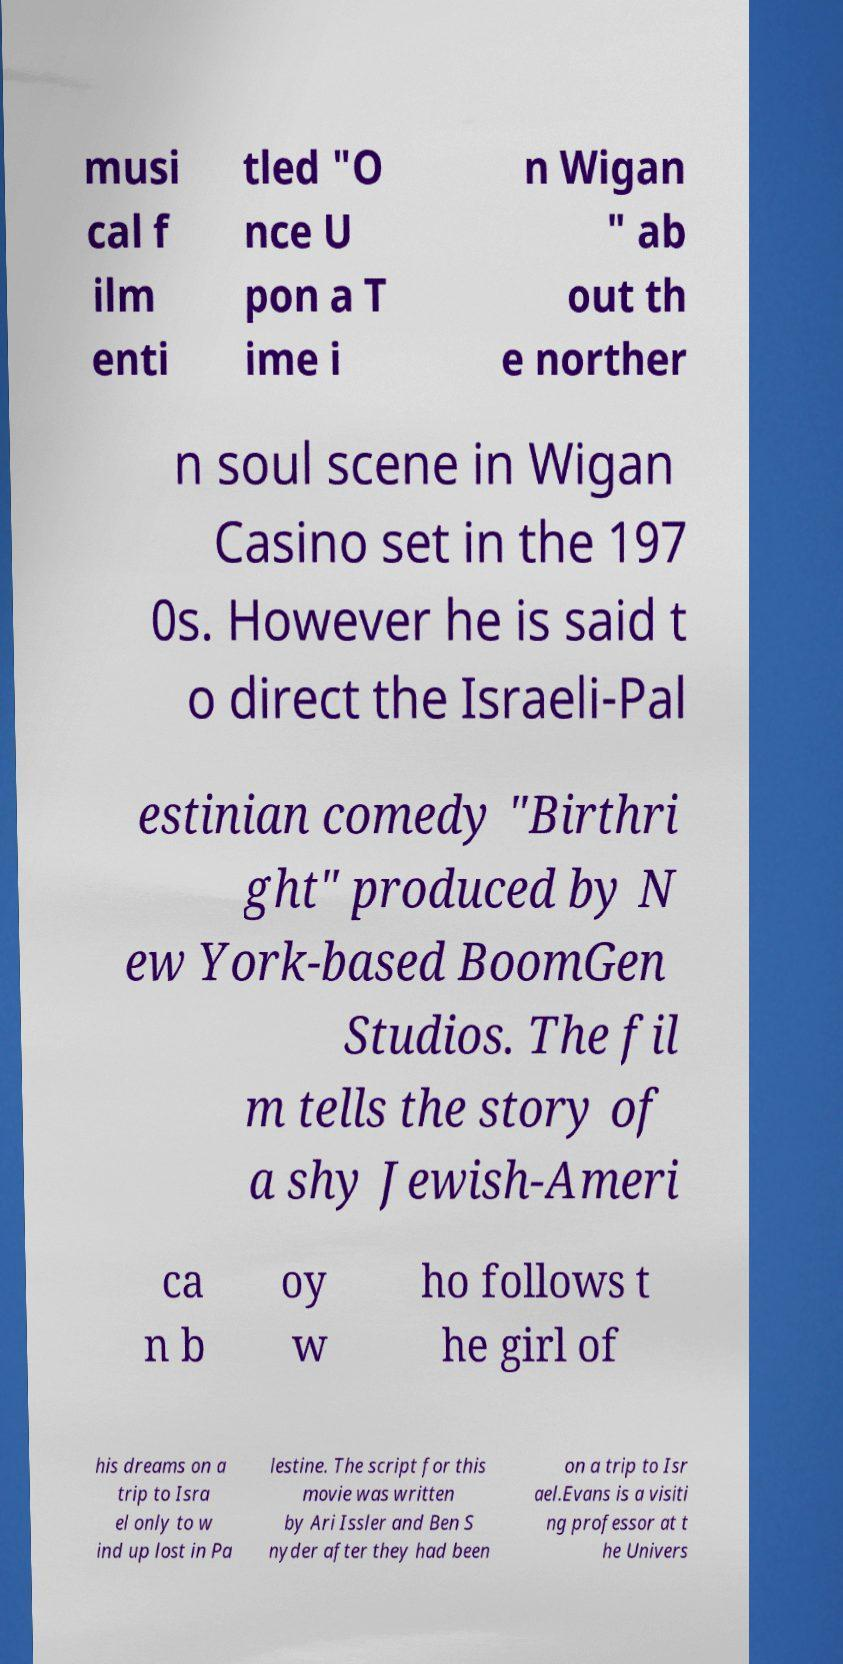Please identify and transcribe the text found in this image. musi cal f ilm enti tled "O nce U pon a T ime i n Wigan " ab out th e norther n soul scene in Wigan Casino set in the 197 0s. However he is said t o direct the Israeli-Pal estinian comedy "Birthri ght" produced by N ew York-based BoomGen Studios. The fil m tells the story of a shy Jewish-Ameri ca n b oy w ho follows t he girl of his dreams on a trip to Isra el only to w ind up lost in Pa lestine. The script for this movie was written by Ari Issler and Ben S nyder after they had been on a trip to Isr ael.Evans is a visiti ng professor at t he Univers 